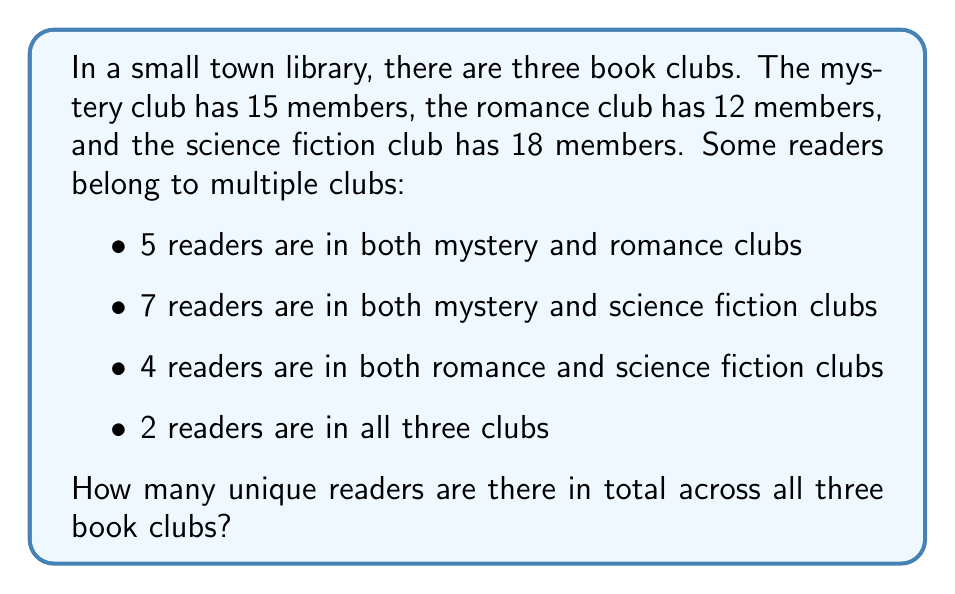Teach me how to tackle this problem. To solve this problem, we'll use the principle of inclusion-exclusion for three sets. Let's define our sets:

$M$ = Mystery club members
$R$ = Romance club members
$S$ = Science fiction club members

We're given:
$|M| = 15$, $|R| = 12$, $|S| = 18$
$|M \cap R| = 5$, $|M \cap S| = 7$, $|R \cap S| = 4$
$|M \cap R \cap S| = 2$

The formula for the cardinality of the union of three sets is:

$$|M \cup R \cup S| = |M| + |R| + |S| - |M \cap R| - |M \cap S| - |R \cap S| + |M \cap R \cap S|$$

Now, let's substitute our values:

$$|M \cup R \cup S| = 15 + 12 + 18 - 5 - 7 - 4 + 2$$

Simplifying:
$$|M \cup R \cup S| = 45 - 16 + 2 = 31$$

Therefore, there are 31 unique readers across all three book clubs.
Answer: 31 unique readers 